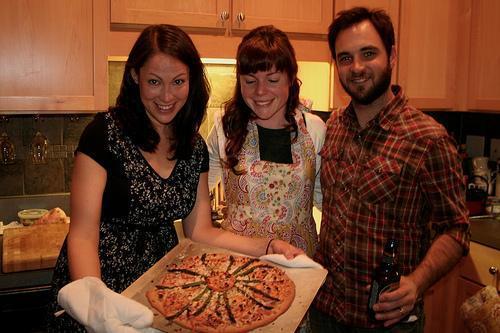How many people are shown?
Give a very brief answer. 3. How many people are in the photo?
Give a very brief answer. 3. How many gray elephants are there?
Give a very brief answer. 0. 